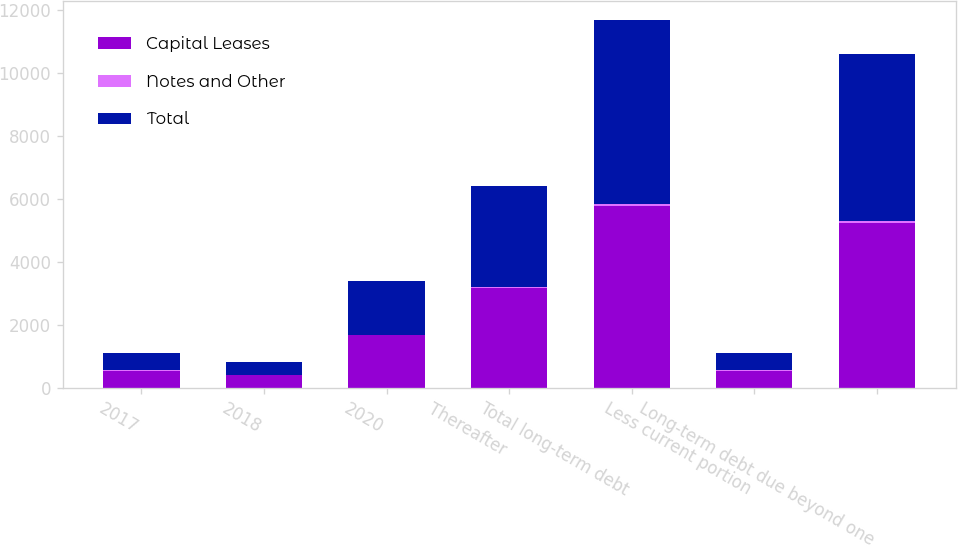<chart> <loc_0><loc_0><loc_500><loc_500><stacked_bar_chart><ecel><fcel>2017<fcel>2018<fcel>2020<fcel>Thereafter<fcel>Total long-term debt<fcel>Less current portion<fcel>Long-term debt due beyond one<nl><fcel>Capital Leases<fcel>541.1<fcel>400<fcel>1679.6<fcel>3157<fcel>5777.7<fcel>541.1<fcel>5236.6<nl><fcel>Notes and Other<fcel>14.9<fcel>14.4<fcel>12.5<fcel>45.5<fcel>71.8<fcel>8.4<fcel>63.4<nl><fcel>Total<fcel>556<fcel>414.4<fcel>1692.1<fcel>3202.5<fcel>5849.5<fcel>549.5<fcel>5300<nl></chart> 